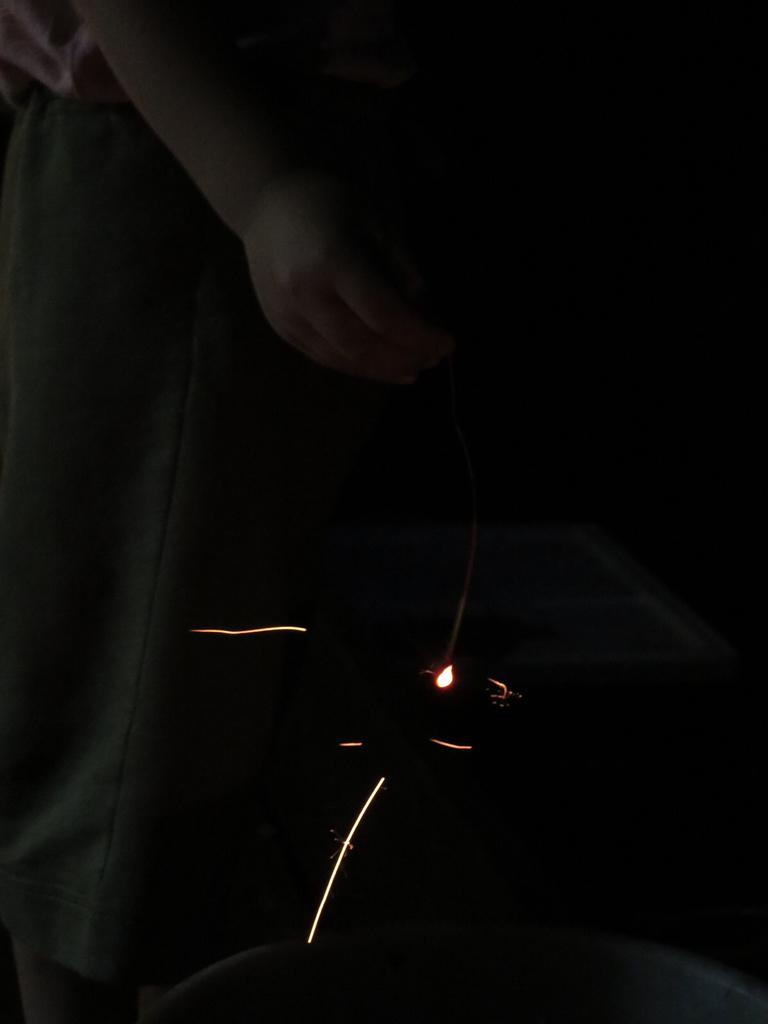What is present in the image? There is a person in the image. What is the person doing in the image? The person is holding an object. What type of fuel is the person using to power the object in the image? There is no information about fuel or powering an object in the image. The person is simply holding an object, and the nature of the object is not specified. 